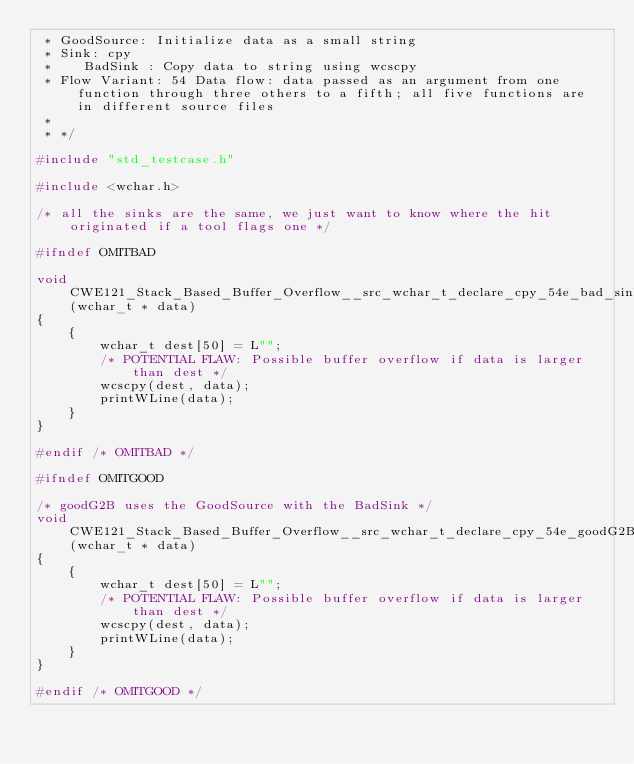<code> <loc_0><loc_0><loc_500><loc_500><_C_> * GoodSource: Initialize data as a small string
 * Sink: cpy
 *    BadSink : Copy data to string using wcscpy
 * Flow Variant: 54 Data flow: data passed as an argument from one function through three others to a fifth; all five functions are in different source files
 *
 * */

#include "std_testcase.h"

#include <wchar.h>

/* all the sinks are the same, we just want to know where the hit originated if a tool flags one */

#ifndef OMITBAD

void CWE121_Stack_Based_Buffer_Overflow__src_wchar_t_declare_cpy_54e_bad_sink(wchar_t * data)
{
    {
        wchar_t dest[50] = L"";
        /* POTENTIAL FLAW: Possible buffer overflow if data is larger than dest */
        wcscpy(dest, data);
        printWLine(data);
    }
}

#endif /* OMITBAD */

#ifndef OMITGOOD

/* goodG2B uses the GoodSource with the BadSink */
void CWE121_Stack_Based_Buffer_Overflow__src_wchar_t_declare_cpy_54e_goodG2B_sink(wchar_t * data)
{
    {
        wchar_t dest[50] = L"";
        /* POTENTIAL FLAW: Possible buffer overflow if data is larger than dest */
        wcscpy(dest, data);
        printWLine(data);
    }
}

#endif /* OMITGOOD */
</code> 